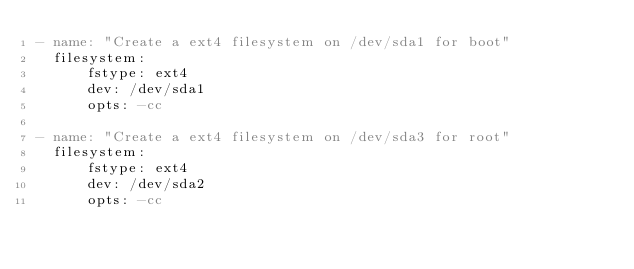Convert code to text. <code><loc_0><loc_0><loc_500><loc_500><_YAML_>- name: "Create a ext4 filesystem on /dev/sda1 for boot"
  filesystem:
      fstype: ext4
      dev: /dev/sda1
      opts: -cc

- name: "Create a ext4 filesystem on /dev/sda3 for root"
  filesystem:
      fstype: ext4
      dev: /dev/sda2
      opts: -cc
</code> 